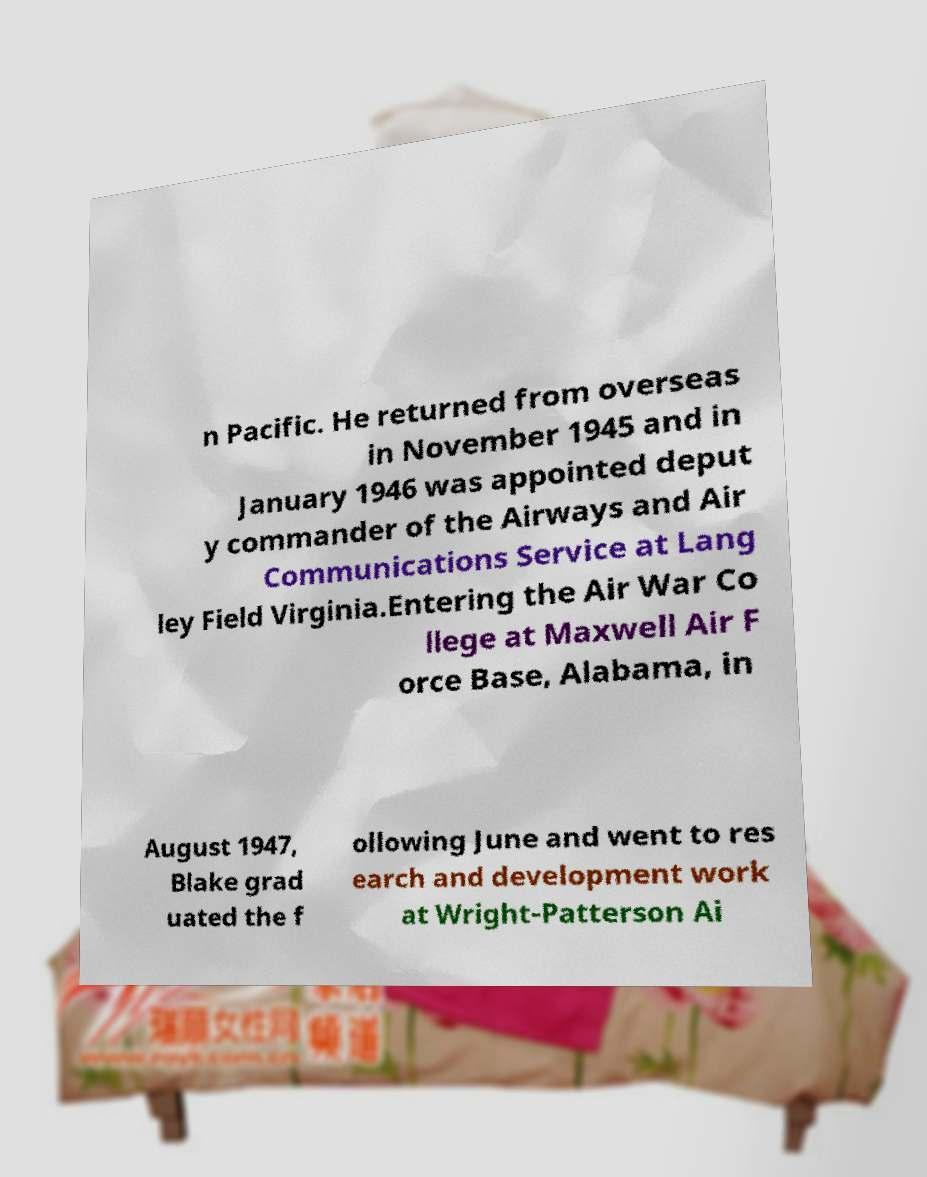Could you assist in decoding the text presented in this image and type it out clearly? n Pacific. He returned from overseas in November 1945 and in January 1946 was appointed deput y commander of the Airways and Air Communications Service at Lang ley Field Virginia.Entering the Air War Co llege at Maxwell Air F orce Base, Alabama, in August 1947, Blake grad uated the f ollowing June and went to res earch and development work at Wright-Patterson Ai 